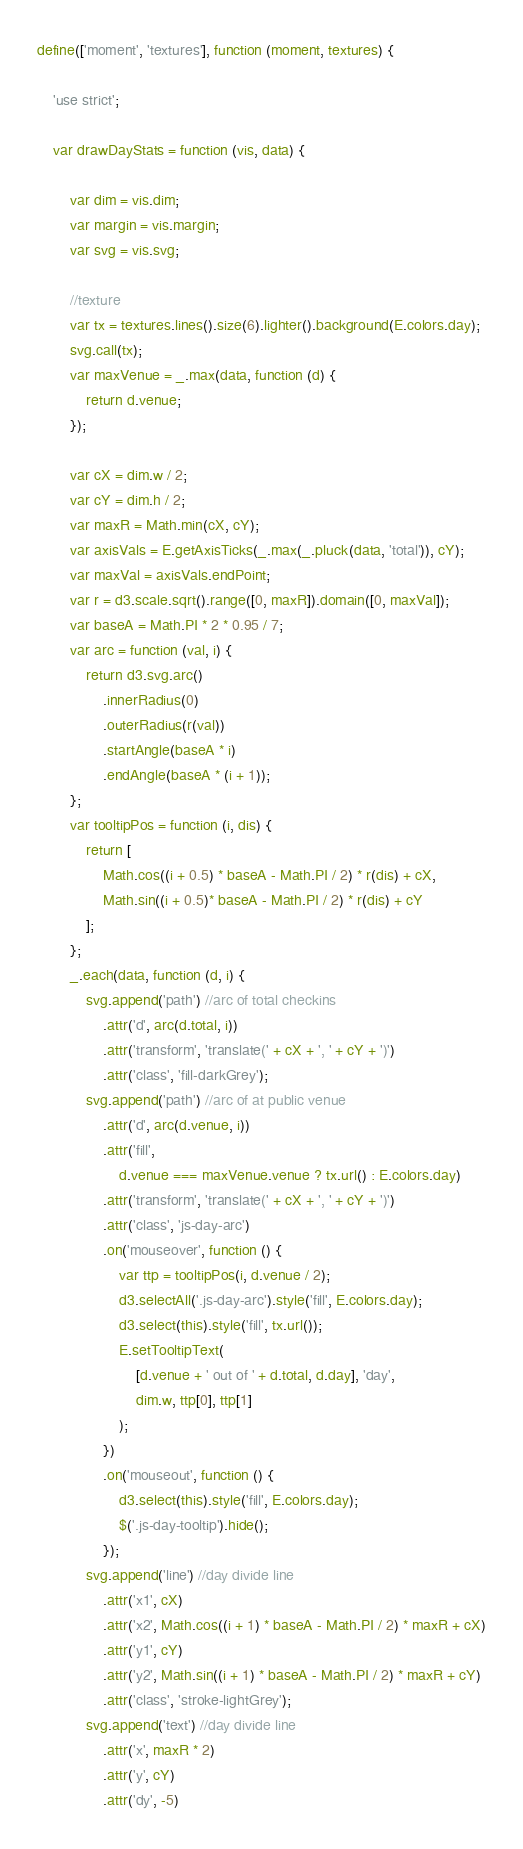<code> <loc_0><loc_0><loc_500><loc_500><_JavaScript_>define(['moment', 'textures'], function (moment, textures) {

    'use strict';

    var drawDayStats = function (vis, data) {

        var dim = vis.dim;
        var margin = vis.margin;
        var svg = vis.svg;

        //texture
        var tx = textures.lines().size(6).lighter().background(E.colors.day);
        svg.call(tx);
        var maxVenue = _.max(data, function (d) {
            return d.venue;
        });

        var cX = dim.w / 2;
        var cY = dim.h / 2;
        var maxR = Math.min(cX, cY);
        var axisVals = E.getAxisTicks(_.max(_.pluck(data, 'total')), cY);
        var maxVal = axisVals.endPoint;
        var r = d3.scale.sqrt().range([0, maxR]).domain([0, maxVal]);
        var baseA = Math.PI * 2 * 0.95 / 7;
        var arc = function (val, i) {
            return d3.svg.arc()
                .innerRadius(0)
                .outerRadius(r(val))
                .startAngle(baseA * i)
                .endAngle(baseA * (i + 1));
        };
        var tooltipPos = function (i, dis) {
            return [
                Math.cos((i + 0.5) * baseA - Math.PI / 2) * r(dis) + cX,
                Math.sin((i + 0.5)* baseA - Math.PI / 2) * r(dis) + cY
            ];
        };
        _.each(data, function (d, i) {
            svg.append('path') //arc of total checkins
                .attr('d', arc(d.total, i))
                .attr('transform', 'translate(' + cX + ', ' + cY + ')')
                .attr('class', 'fill-darkGrey');
            svg.append('path') //arc of at public venue
                .attr('d', arc(d.venue, i))
                .attr('fill',
                    d.venue === maxVenue.venue ? tx.url() : E.colors.day)
                .attr('transform', 'translate(' + cX + ', ' + cY + ')')
                .attr('class', 'js-day-arc')
                .on('mouseover', function () {
                    var ttp = tooltipPos(i, d.venue / 2);
                    d3.selectAll('.js-day-arc').style('fill', E.colors.day);
                    d3.select(this).style('fill', tx.url());
                    E.setTooltipText(
                        [d.venue + ' out of ' + d.total, d.day], 'day',
                        dim.w, ttp[0], ttp[1]
                    );
                })
                .on('mouseout', function () {
                    d3.select(this).style('fill', E.colors.day);
                    $('.js-day-tooltip').hide();
                });
            svg.append('line') //day divide line
                .attr('x1', cX)
                .attr('x2', Math.cos((i + 1) * baseA - Math.PI / 2) * maxR + cX)
                .attr('y1', cY)
                .attr('y2', Math.sin((i + 1) * baseA - Math.PI / 2) * maxR + cY)
                .attr('class', 'stroke-lightGrey');
            svg.append('text') //day divide line
                .attr('x', maxR * 2)
                .attr('y', cY)
                .attr('dy', -5)</code> 